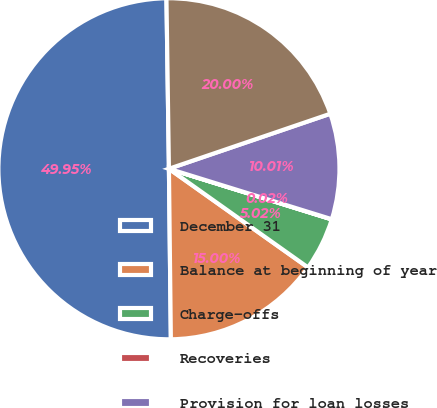Convert chart. <chart><loc_0><loc_0><loc_500><loc_500><pie_chart><fcel>December 31<fcel>Balance at beginning of year<fcel>Charge-offs<fcel>Recoveries<fcel>Provision for loan losses<fcel>Balance at end of year<nl><fcel>49.95%<fcel>15.0%<fcel>5.02%<fcel>0.02%<fcel>10.01%<fcel>20.0%<nl></chart> 